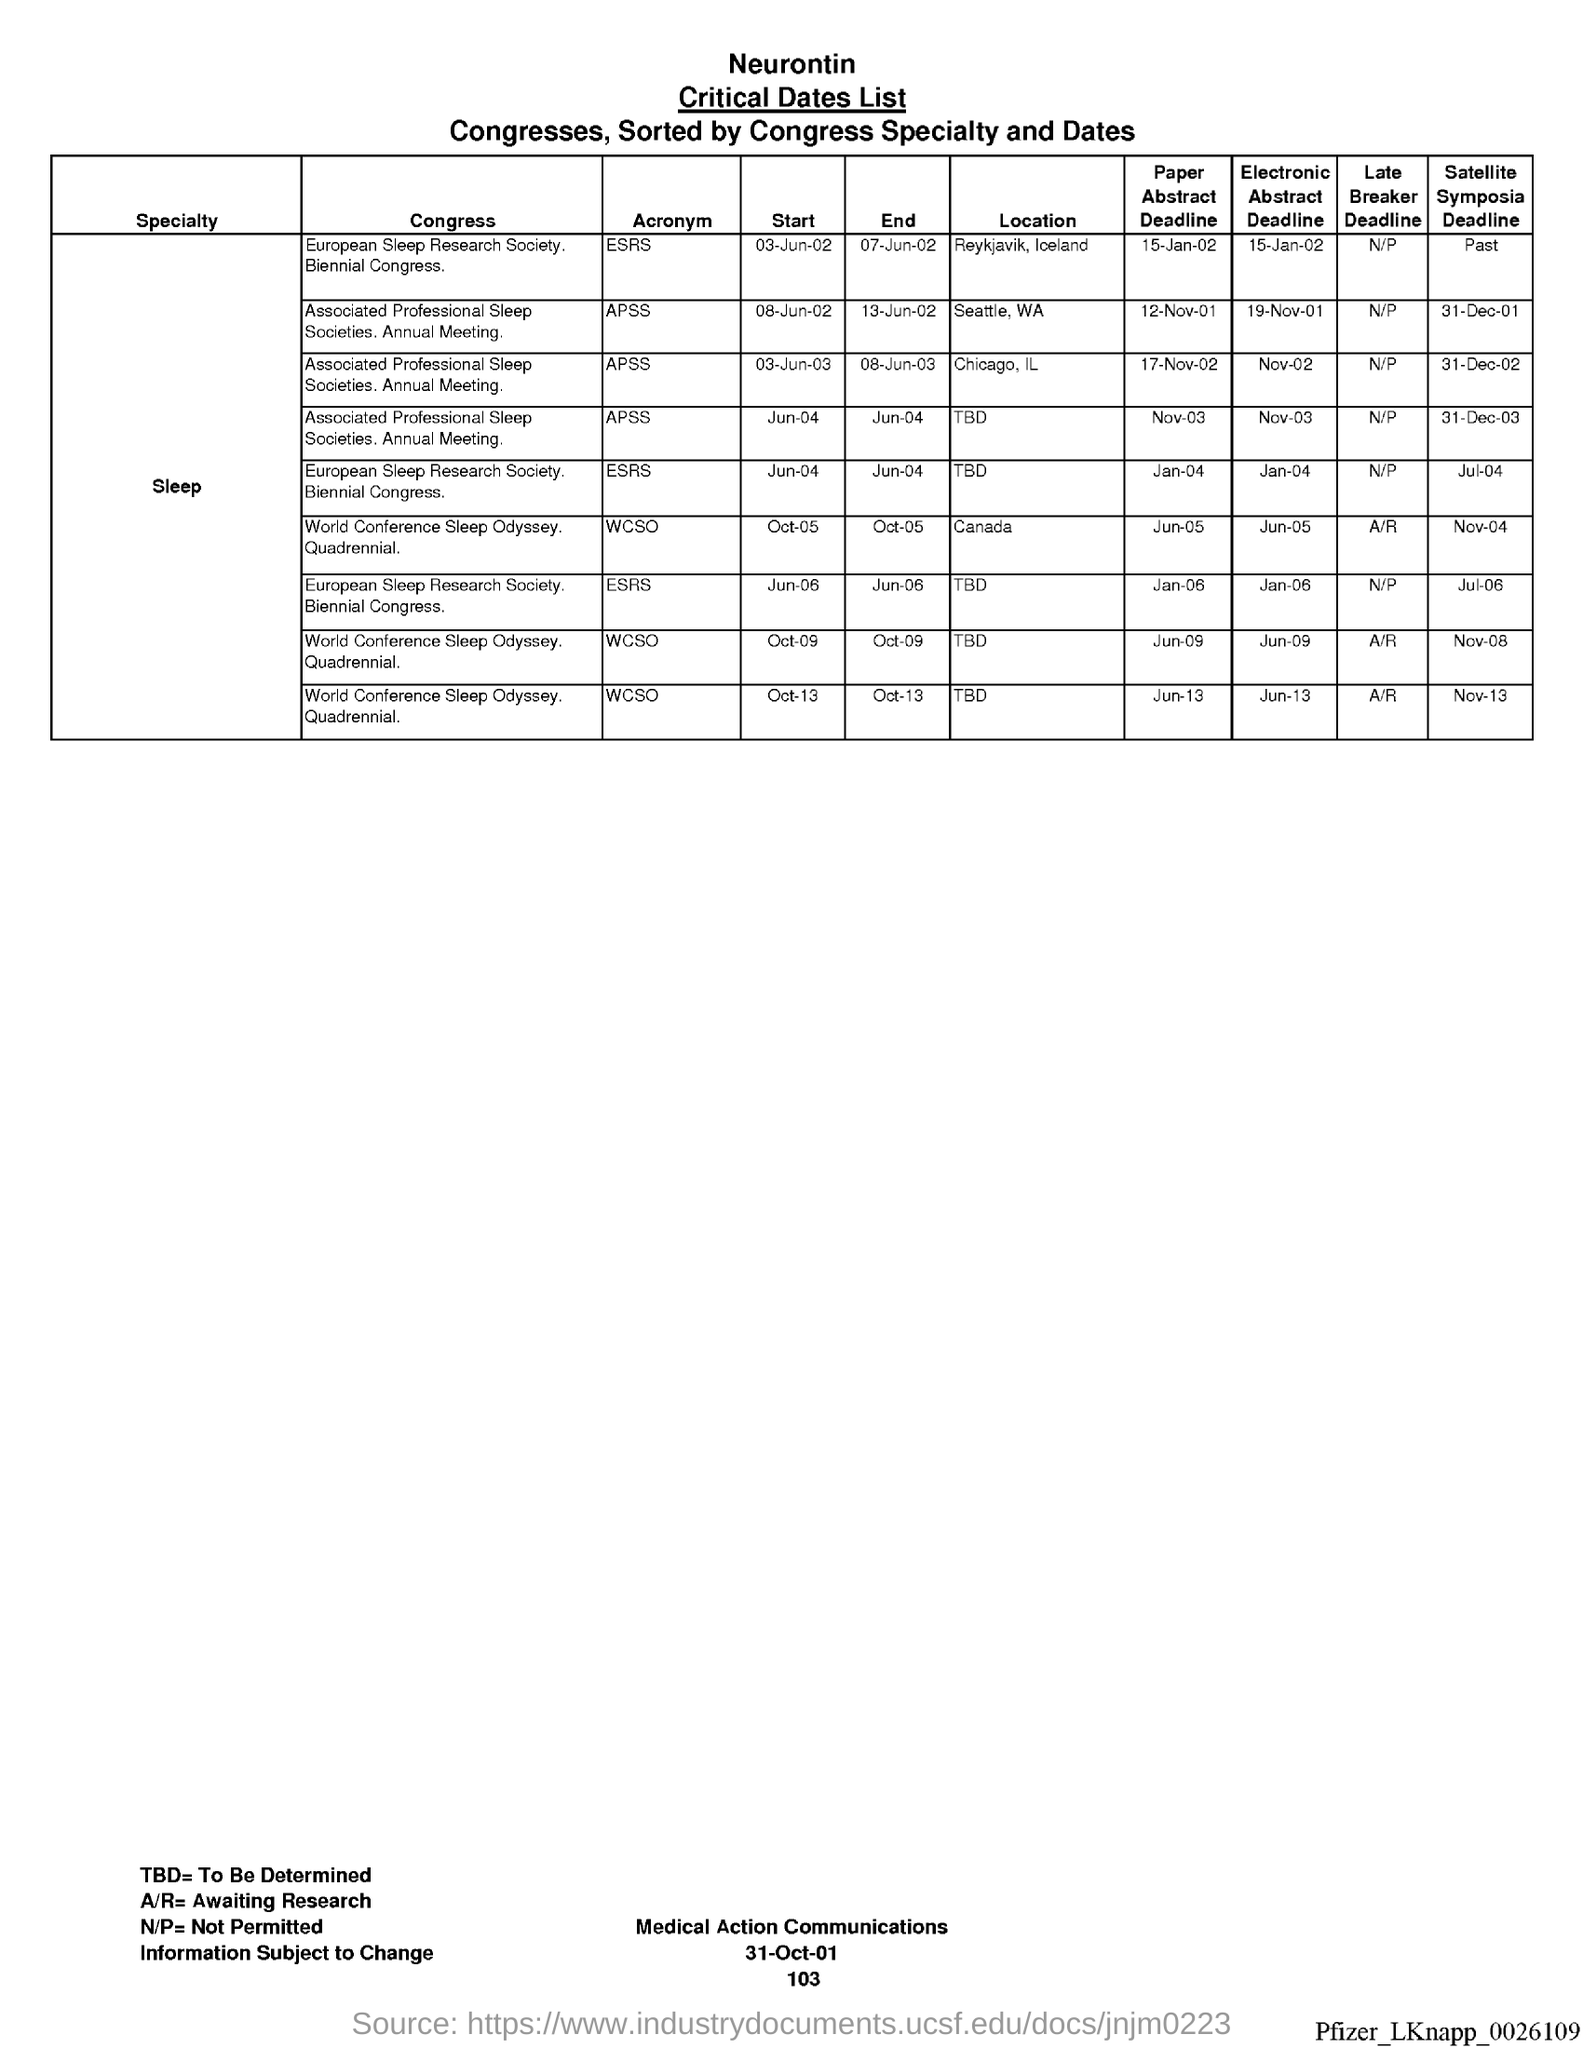What is the acronym for european sleep research society ?
Your response must be concise. Esrs. What is the acronym for associated professional sleep societies ?
Your answer should be very brief. Apss. What is the acronym for world conference sleep odyssey ?
Give a very brief answer. WCSO. What is tbd= ?
Make the answer very short. To be determined. What is a/r= ?
Offer a terse response. Awaiting research. What is n/p =?
Keep it short and to the point. Not permitted. What is the date at bottom of the page?
Ensure brevity in your answer.  31-Oct-01. What is the page number below date?
Your answer should be compact. 103. 